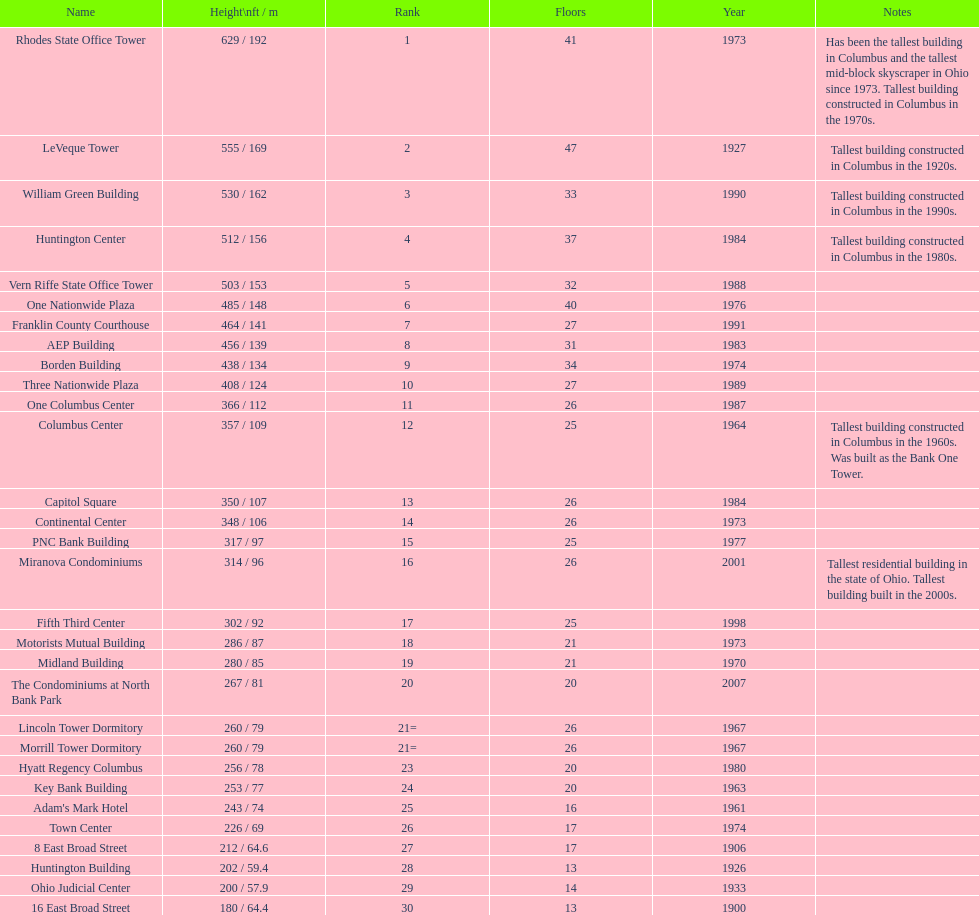How many floors does the capitol square have? 26. 